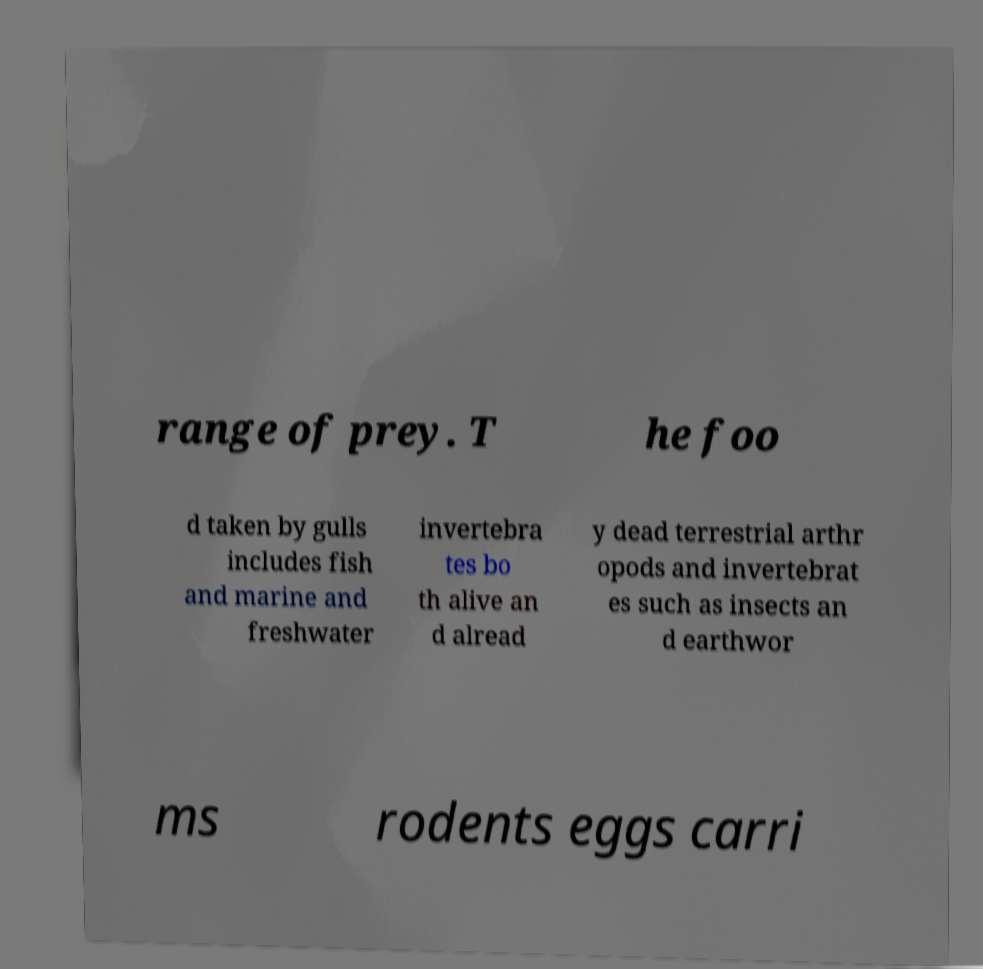Could you extract and type out the text from this image? range of prey. T he foo d taken by gulls includes fish and marine and freshwater invertebra tes bo th alive an d alread y dead terrestrial arthr opods and invertebrat es such as insects an d earthwor ms rodents eggs carri 